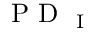Convert formula to latex. <formula><loc_0><loc_0><loc_500><loc_500>P D _ { I }</formula> 